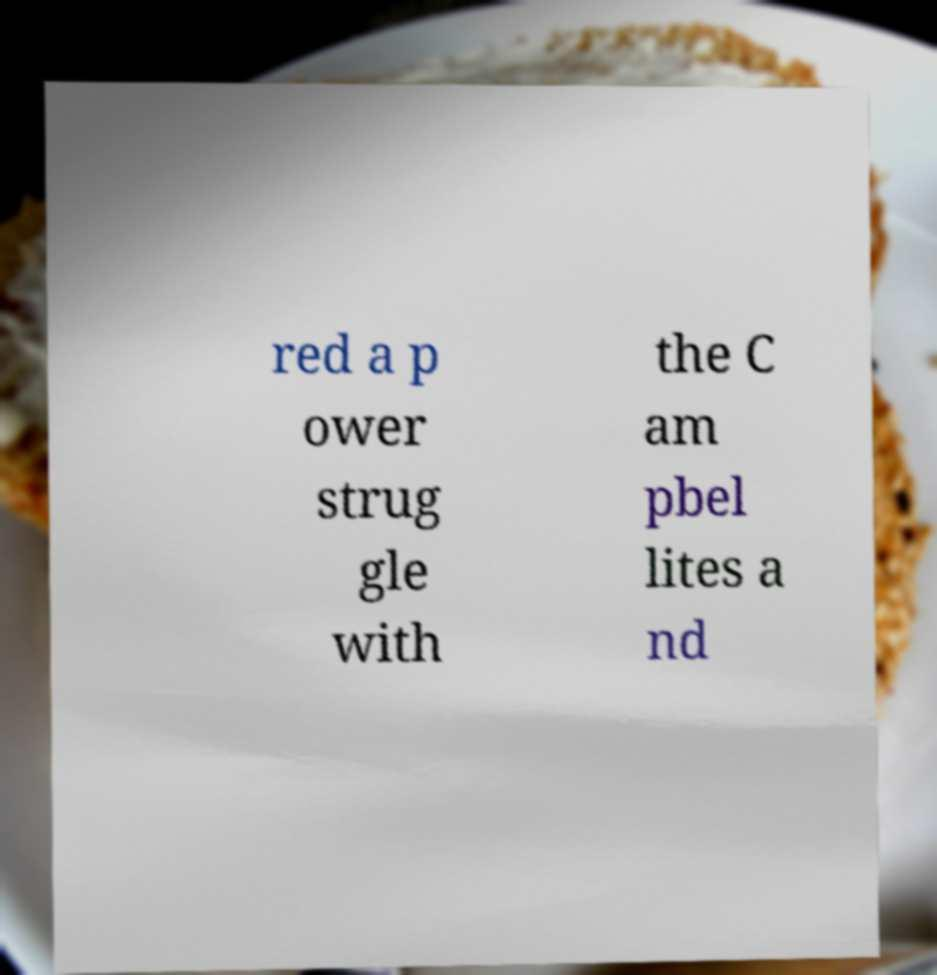I need the written content from this picture converted into text. Can you do that? red a p ower strug gle with the C am pbel lites a nd 